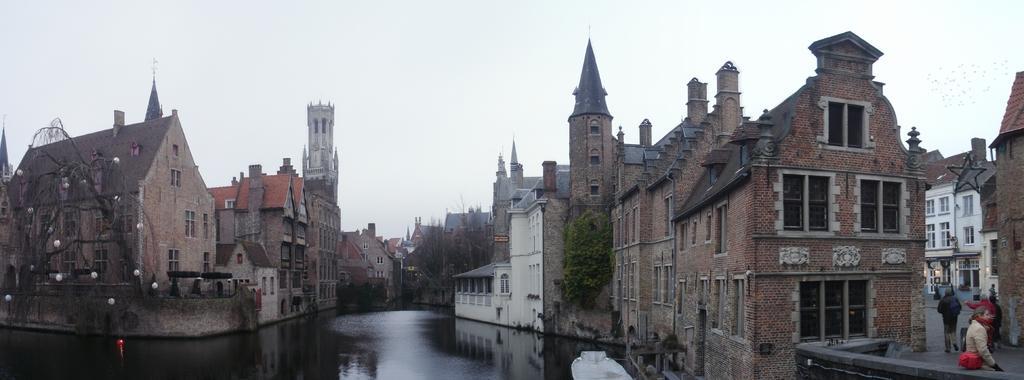Can you describe this image briefly? At the bottom of the picture, we see water and this water might be in the canal. On either side of the canal, we see the trees and buildings. On the right side, we see the people are walking on the road. Beside them, we see the buildings. In the background, we see the buildings and trees. At the top, we see the sky. 